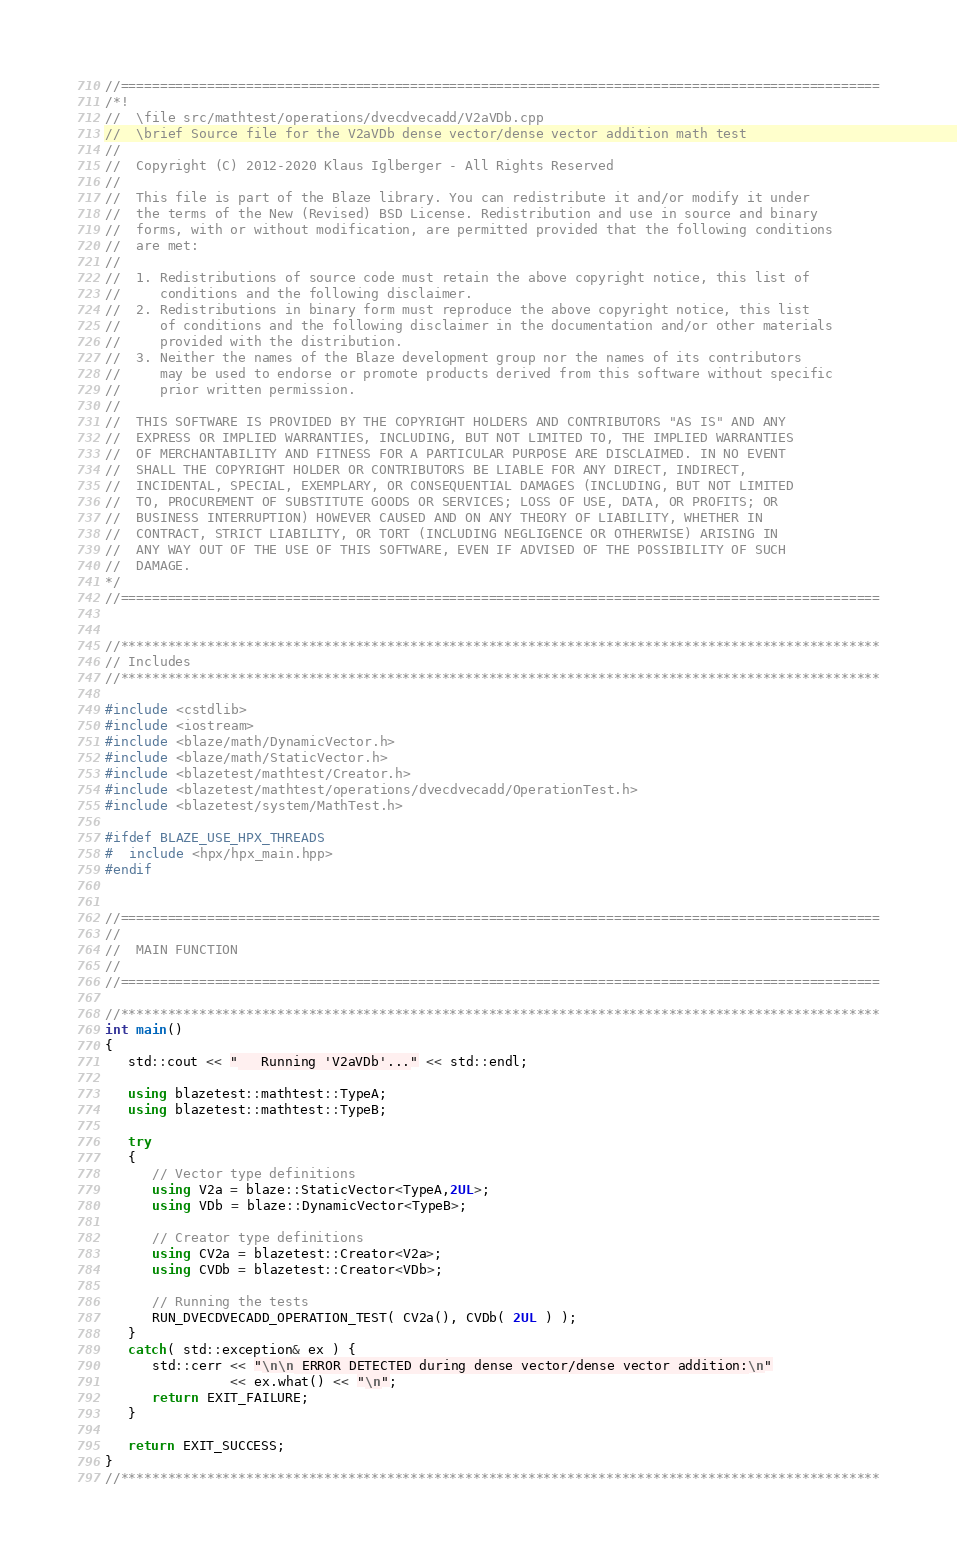<code> <loc_0><loc_0><loc_500><loc_500><_C++_>//=================================================================================================
/*!
//  \file src/mathtest/operations/dvecdvecadd/V2aVDb.cpp
//  \brief Source file for the V2aVDb dense vector/dense vector addition math test
//
//  Copyright (C) 2012-2020 Klaus Iglberger - All Rights Reserved
//
//  This file is part of the Blaze library. You can redistribute it and/or modify it under
//  the terms of the New (Revised) BSD License. Redistribution and use in source and binary
//  forms, with or without modification, are permitted provided that the following conditions
//  are met:
//
//  1. Redistributions of source code must retain the above copyright notice, this list of
//     conditions and the following disclaimer.
//  2. Redistributions in binary form must reproduce the above copyright notice, this list
//     of conditions and the following disclaimer in the documentation and/or other materials
//     provided with the distribution.
//  3. Neither the names of the Blaze development group nor the names of its contributors
//     may be used to endorse or promote products derived from this software without specific
//     prior written permission.
//
//  THIS SOFTWARE IS PROVIDED BY THE COPYRIGHT HOLDERS AND CONTRIBUTORS "AS IS" AND ANY
//  EXPRESS OR IMPLIED WARRANTIES, INCLUDING, BUT NOT LIMITED TO, THE IMPLIED WARRANTIES
//  OF MERCHANTABILITY AND FITNESS FOR A PARTICULAR PURPOSE ARE DISCLAIMED. IN NO EVENT
//  SHALL THE COPYRIGHT HOLDER OR CONTRIBUTORS BE LIABLE FOR ANY DIRECT, INDIRECT,
//  INCIDENTAL, SPECIAL, EXEMPLARY, OR CONSEQUENTIAL DAMAGES (INCLUDING, BUT NOT LIMITED
//  TO, PROCUREMENT OF SUBSTITUTE GOODS OR SERVICES; LOSS OF USE, DATA, OR PROFITS; OR
//  BUSINESS INTERRUPTION) HOWEVER CAUSED AND ON ANY THEORY OF LIABILITY, WHETHER IN
//  CONTRACT, STRICT LIABILITY, OR TORT (INCLUDING NEGLIGENCE OR OTHERWISE) ARISING IN
//  ANY WAY OUT OF THE USE OF THIS SOFTWARE, EVEN IF ADVISED OF THE POSSIBILITY OF SUCH
//  DAMAGE.
*/
//=================================================================================================


//*************************************************************************************************
// Includes
//*************************************************************************************************

#include <cstdlib>
#include <iostream>
#include <blaze/math/DynamicVector.h>
#include <blaze/math/StaticVector.h>
#include <blazetest/mathtest/Creator.h>
#include <blazetest/mathtest/operations/dvecdvecadd/OperationTest.h>
#include <blazetest/system/MathTest.h>

#ifdef BLAZE_USE_HPX_THREADS
#  include <hpx/hpx_main.hpp>
#endif


//=================================================================================================
//
//  MAIN FUNCTION
//
//=================================================================================================

//*************************************************************************************************
int main()
{
   std::cout << "   Running 'V2aVDb'..." << std::endl;

   using blazetest::mathtest::TypeA;
   using blazetest::mathtest::TypeB;

   try
   {
      // Vector type definitions
      using V2a = blaze::StaticVector<TypeA,2UL>;
      using VDb = blaze::DynamicVector<TypeB>;

      // Creator type definitions
      using CV2a = blazetest::Creator<V2a>;
      using CVDb = blazetest::Creator<VDb>;

      // Running the tests
      RUN_DVECDVECADD_OPERATION_TEST( CV2a(), CVDb( 2UL ) );
   }
   catch( std::exception& ex ) {
      std::cerr << "\n\n ERROR DETECTED during dense vector/dense vector addition:\n"
                << ex.what() << "\n";
      return EXIT_FAILURE;
   }

   return EXIT_SUCCESS;
}
//*************************************************************************************************
</code> 